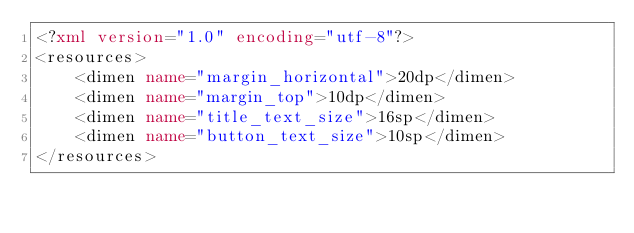Convert code to text. <code><loc_0><loc_0><loc_500><loc_500><_XML_><?xml version="1.0" encoding="utf-8"?>
<resources>
    <dimen name="margin_horizontal">20dp</dimen>
    <dimen name="margin_top">10dp</dimen>
    <dimen name="title_text_size">16sp</dimen>
    <dimen name="button_text_size">10sp</dimen>
</resources></code> 